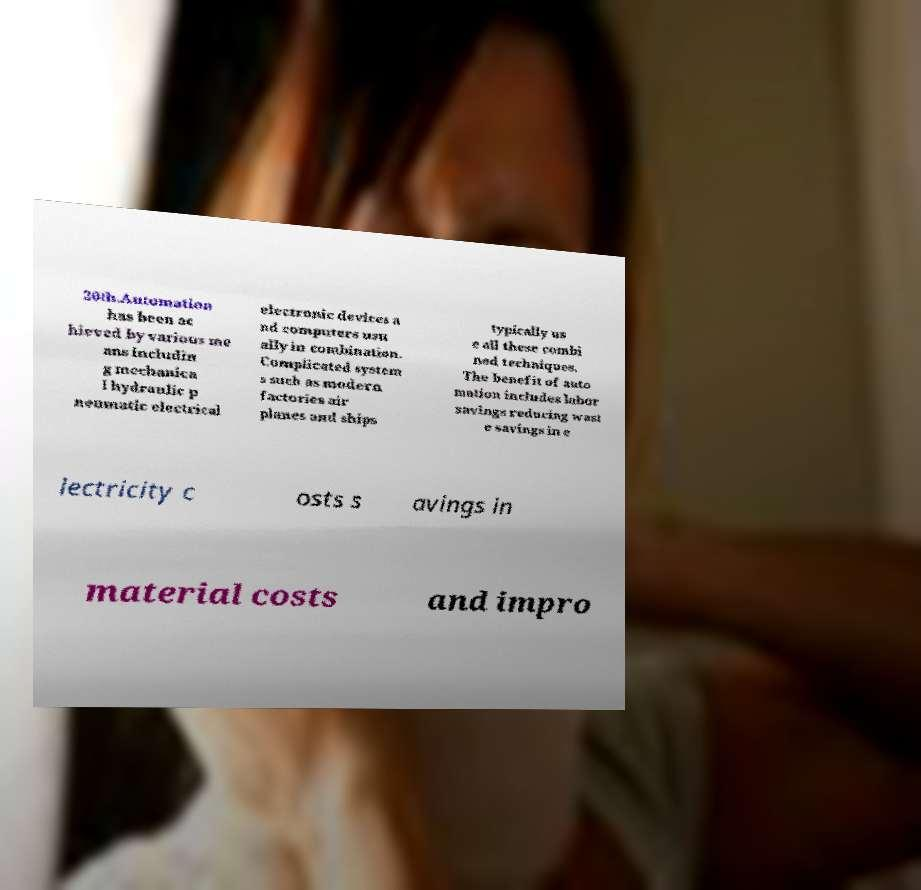Could you assist in decoding the text presented in this image and type it out clearly? 20th.Automation has been ac hieved by various me ans includin g mechanica l hydraulic p neumatic electrical electronic devices a nd computers usu ally in combination. Complicated system s such as modern factories air planes and ships typically us e all these combi ned techniques. The benefit of auto mation includes labor savings reducing wast e savings in e lectricity c osts s avings in material costs and impro 